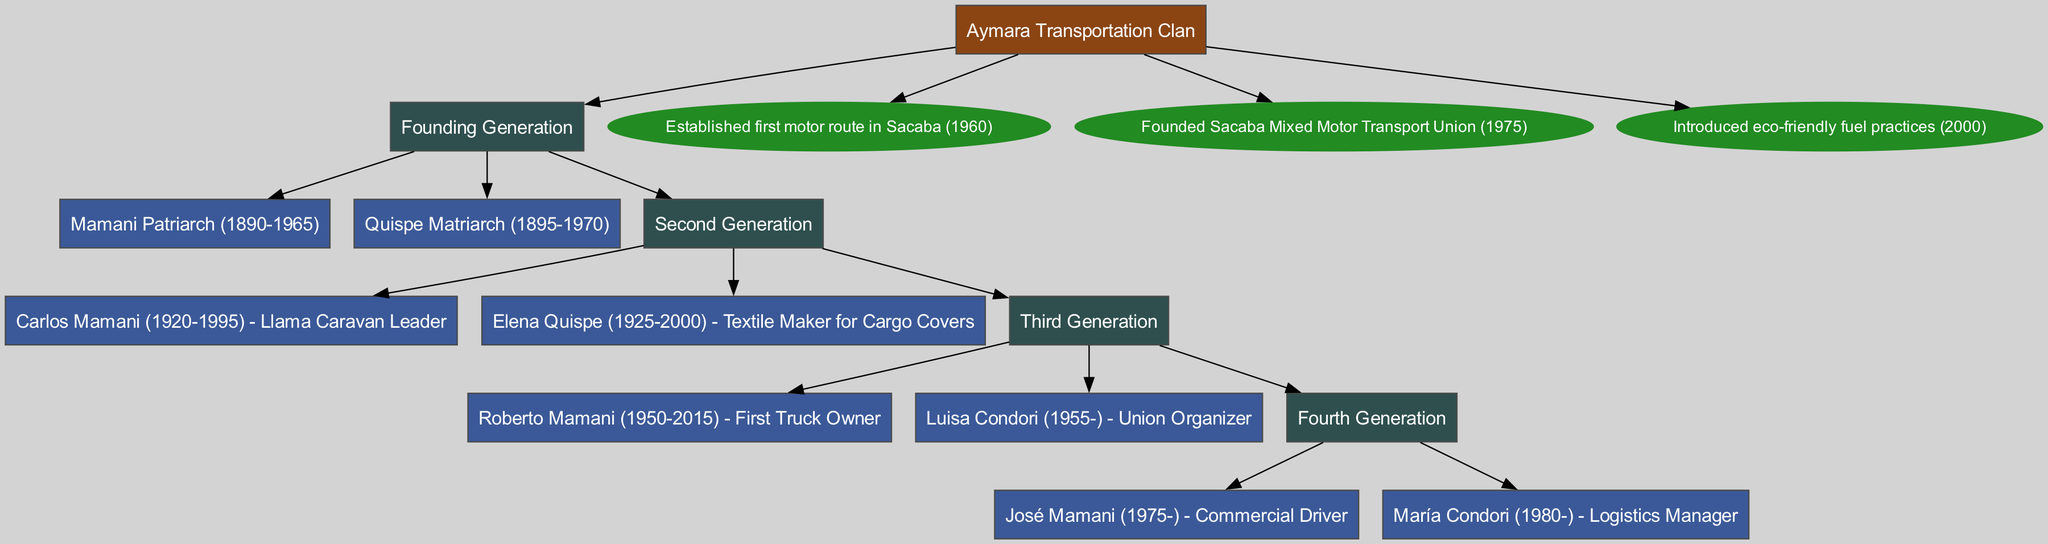What is the name of the root node? The root node in the diagram is labeled as "Aymara Transportation Clan." This name represents the entire family tree, which serves as the foundation for the generations and achievements that follow.
Answer: Aymara Transportation Clan Who are the members of the Founding Generation? The Founding Generation consists of two members: "Mamani Patriarch (1890-1965)" and "Quispe Matriarch (1895-1970)." This information can be found directly under the Founding Generation node in the diagram.
Answer: Mamani Patriarch, Quispe Matriarch Which member of the second generation was involved in crafting cargo covers? The member engaged in crafting cargo covers from the second generation is "Elena Quispe (1925-2000) - Textile Maker for Cargo Covers." This can be identified from the corresponding node under the Second Generation.
Answer: Elena Quispe What notable achievement was established in 1975? The achievement established in 1975 is "Founded Sacaba Mixed Motor Transport Union." This detail can be traced from the notable achievements section connected to the root node.
Answer: Founded Sacaba Mixed Motor Transport Union How many generations are represented in the diagram? The diagram represents four generations. This can be determined by counting the distinct generation nodes from the Founding Generation through to the Fourth Generation.
Answer: 4 Who is the first truck owner among the members? The member recognized as the first truck owner is "Roberto Mamani (1950-2015) - First Truck Owner." This information is found under the Third Generation section of the diagram.
Answer: Roberto Mamani What role does María Condori hold in the Fourth Generation? María Condori holds the role of "Logistics Manager." This can be directly observed in the members listed under the Fourth Generation in the diagram.
Answer: Logistics Manager What achievement was introduced in the year 2000? The achievement introduced in 2000 is "Introduced eco-friendly fuel practices." This information is available in the list of notable achievements linked to the root node.
Answer: Introduced eco-friendly fuel practices 